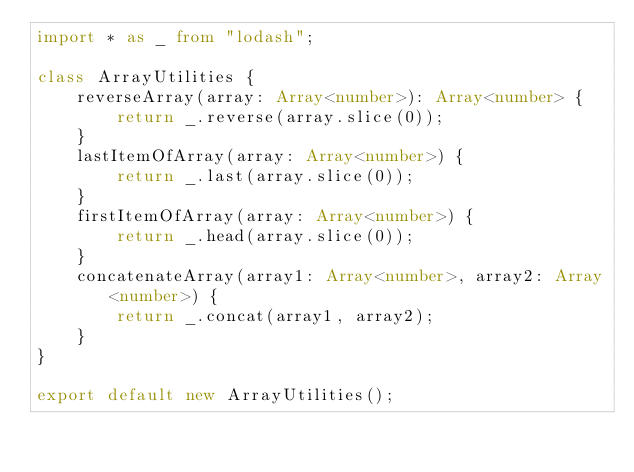<code> <loc_0><loc_0><loc_500><loc_500><_TypeScript_>import * as _ from "lodash";

class ArrayUtilities {
    reverseArray(array: Array<number>): Array<number> {
        return _.reverse(array.slice(0));
    }
    lastItemOfArray(array: Array<number>) {
        return _.last(array.slice(0));
    }
    firstItemOfArray(array: Array<number>) {
        return _.head(array.slice(0));
    }
    concatenateArray(array1: Array<number>, array2: Array<number>) {
        return _.concat(array1, array2);
    }
}

export default new ArrayUtilities();</code> 